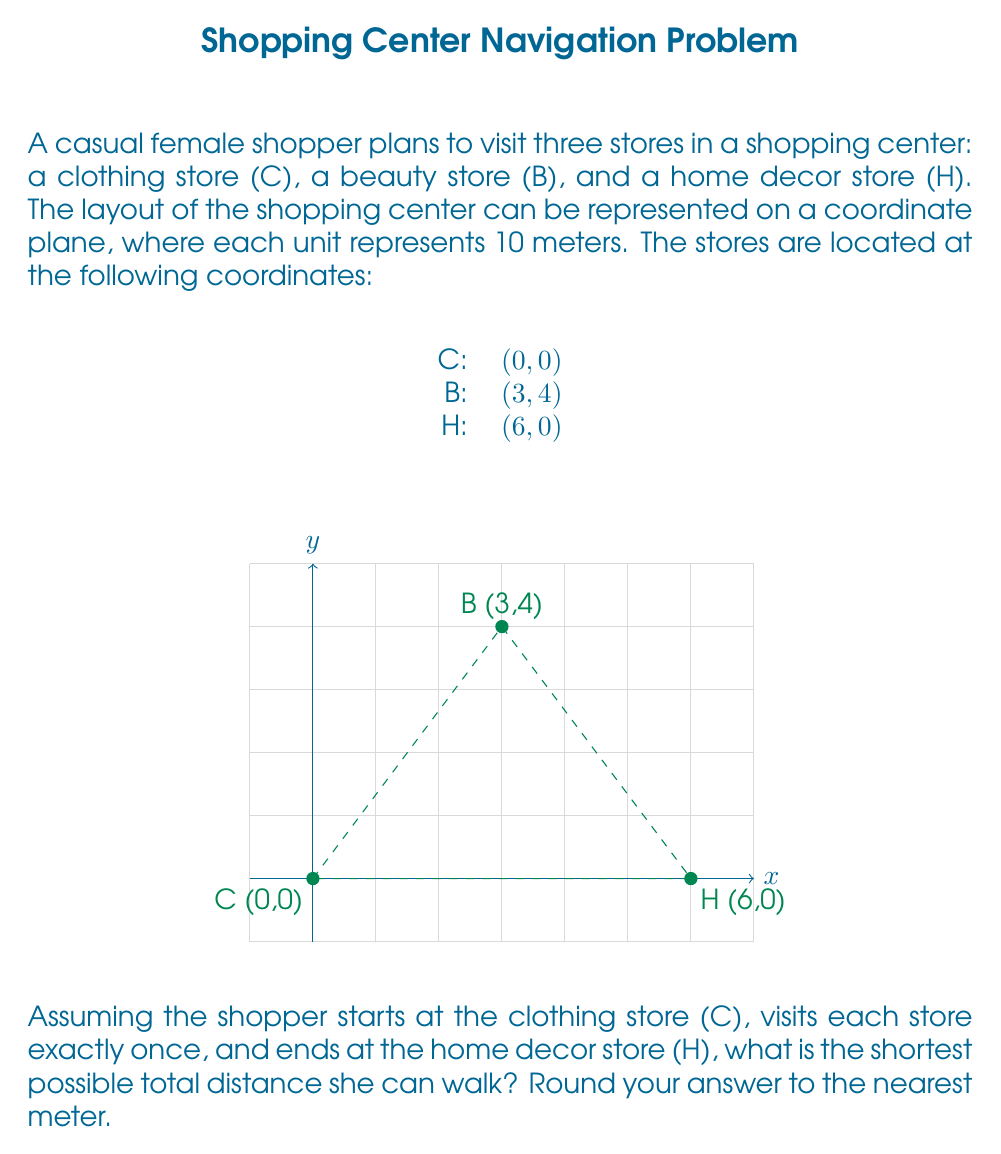Can you answer this question? Let's approach this step-by-step:

1) We need to calculate the distances between each pair of stores using the distance formula:
   $d = \sqrt{(x_2-x_1)^2 + (y_2-y_1)^2}$

2) Distance from C to B:
   $d_{CB} = \sqrt{(3-0)^2 + (4-0)^2} = \sqrt{9 + 16} = \sqrt{25} = 5$ units

3) Distance from B to H:
   $d_{BH} = \sqrt{(6-3)^2 + (0-4)^2} = \sqrt{9 + 16} = \sqrt{25} = 5$ units

4) Distance from C to H:
   $d_{CH} = \sqrt{(6-0)^2 + (0-0)^2} = \sqrt{36} = 6$ units

5) There are two possible routes:
   a) C → B → H
   b) C → H → B

6) Total distance for route a:
   $d_a = d_{CB} + d_{BH} = 5 + 5 = 10$ units

7) Total distance for route b:
   $d_b = d_{CH} + d_{BH} = 6 + 5 = 11$ units

8) The shorter route is a: C → B → H, with a total distance of 10 units.

9) Convert units to meters:
   10 units × 10 meters/unit = 100 meters

Therefore, the shortest possible total distance is 100 meters.
Answer: 100 meters 